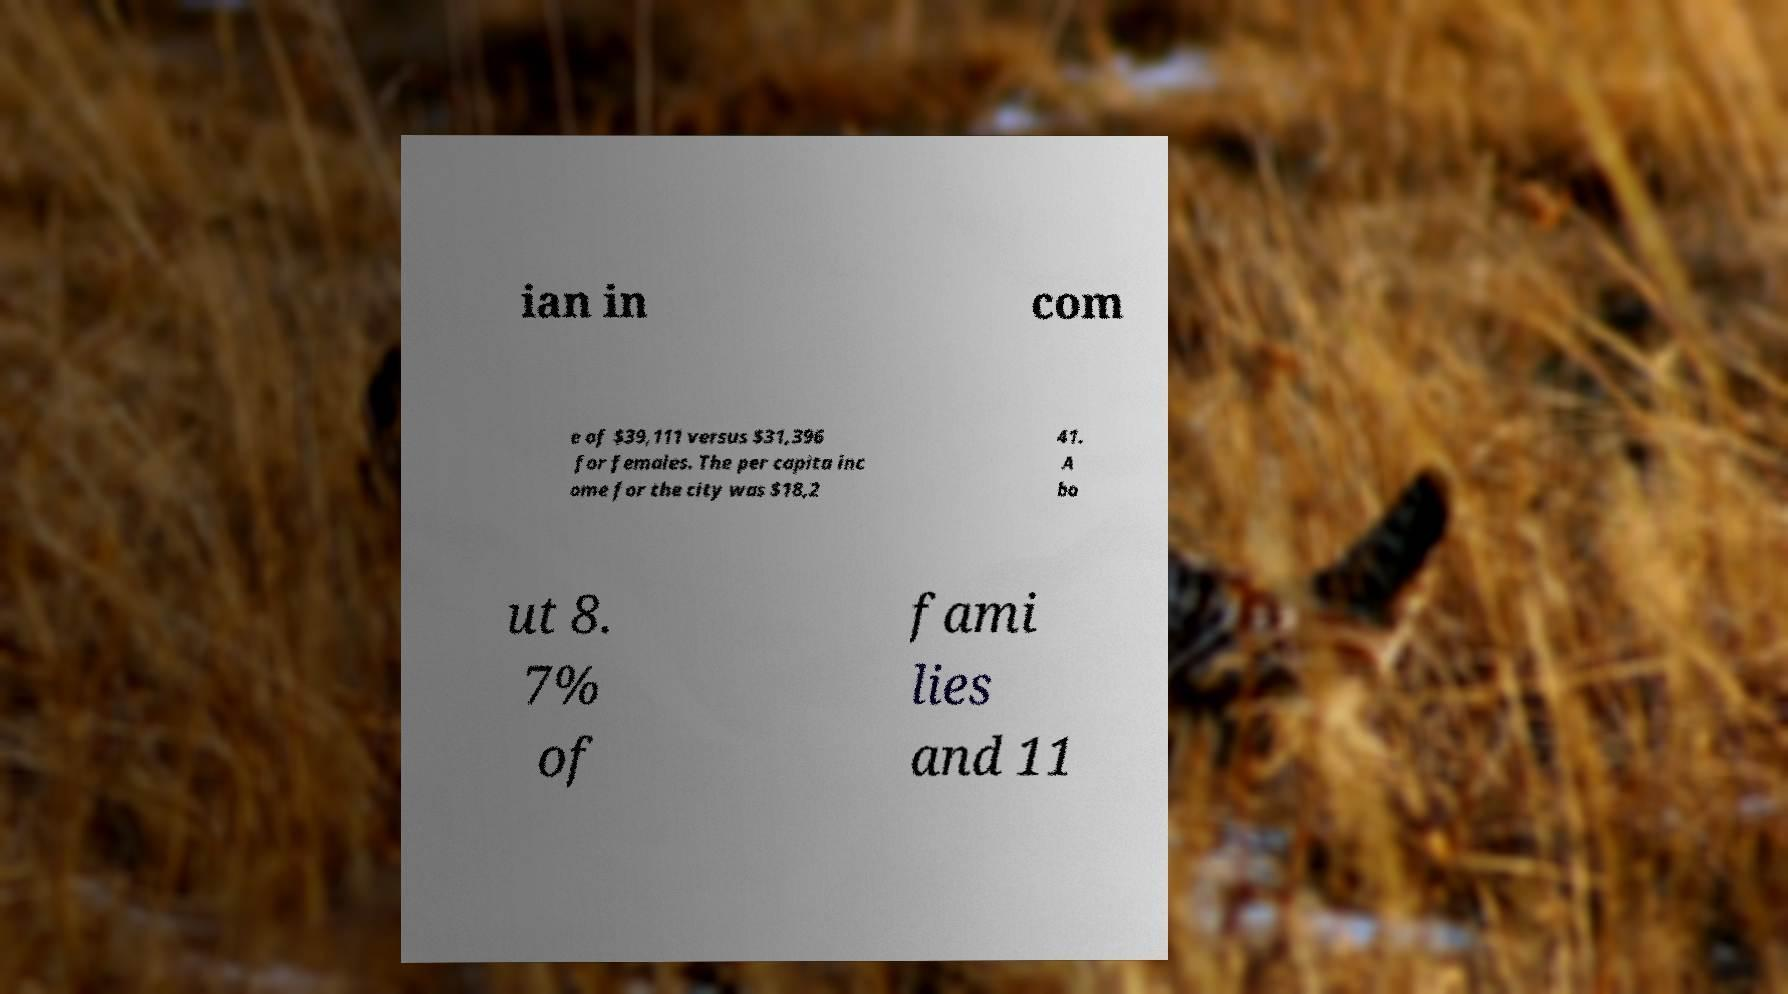There's text embedded in this image that I need extracted. Can you transcribe it verbatim? ian in com e of $39,111 versus $31,396 for females. The per capita inc ome for the city was $18,2 41. A bo ut 8. 7% of fami lies and 11 